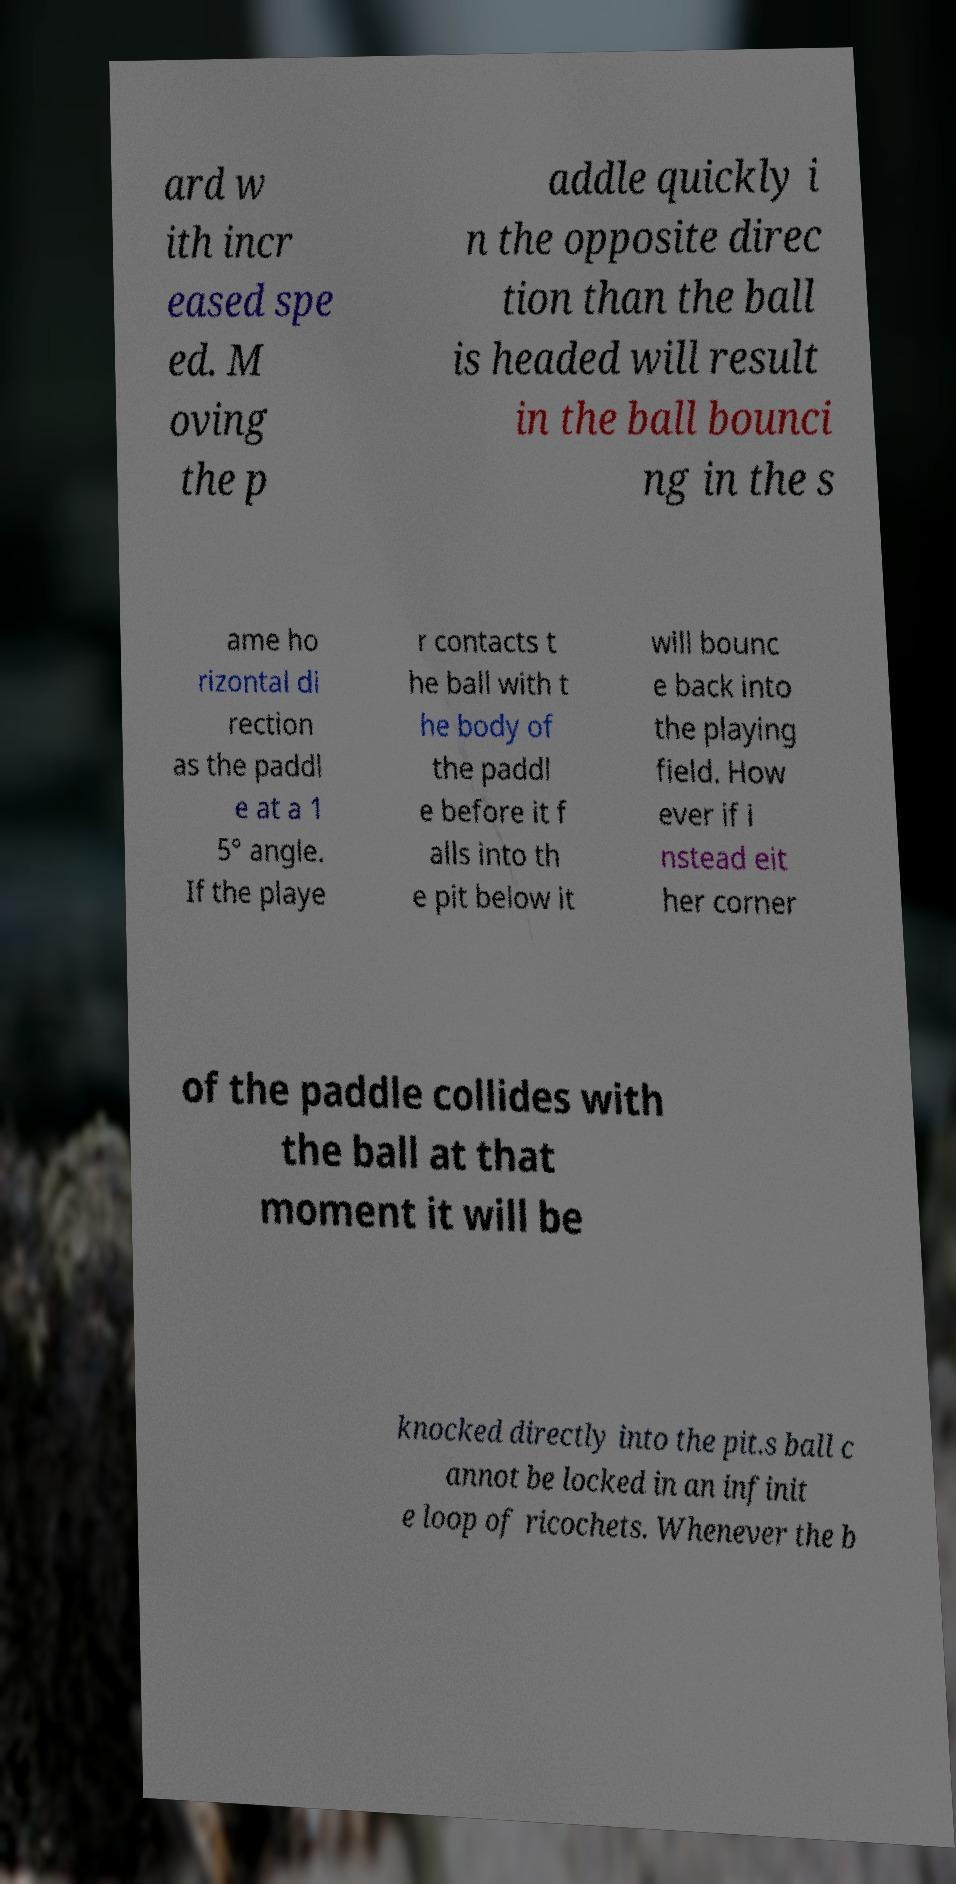For documentation purposes, I need the text within this image transcribed. Could you provide that? ard w ith incr eased spe ed. M oving the p addle quickly i n the opposite direc tion than the ball is headed will result in the ball bounci ng in the s ame ho rizontal di rection as the paddl e at a 1 5° angle. If the playe r contacts t he ball with t he body of the paddl e before it f alls into th e pit below it will bounc e back into the playing field. How ever if i nstead eit her corner of the paddle collides with the ball at that moment it will be knocked directly into the pit.s ball c annot be locked in an infinit e loop of ricochets. Whenever the b 